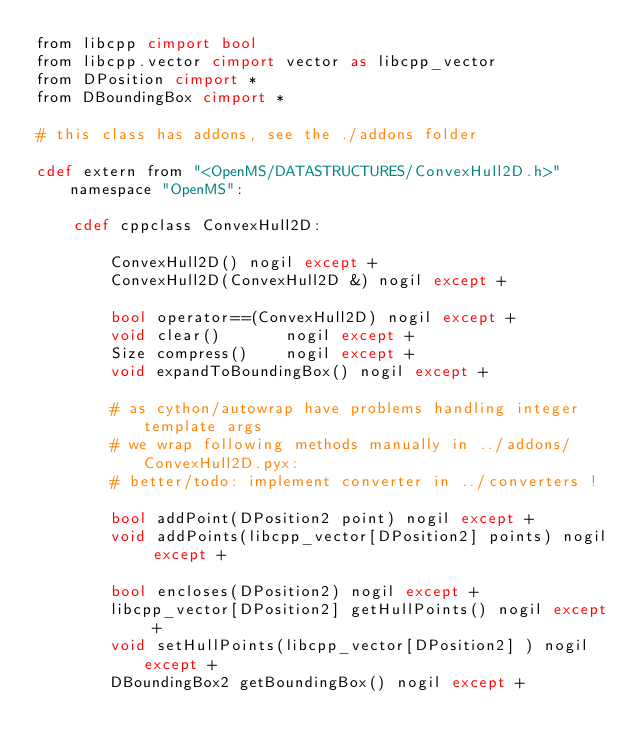<code> <loc_0><loc_0><loc_500><loc_500><_Cython_>from libcpp cimport bool
from libcpp.vector cimport vector as libcpp_vector
from DPosition cimport *
from DBoundingBox cimport *

# this class has addons, see the ./addons folder

cdef extern from "<OpenMS/DATASTRUCTURES/ConvexHull2D.h>" namespace "OpenMS":

    cdef cppclass ConvexHull2D:

        ConvexHull2D() nogil except +
        ConvexHull2D(ConvexHull2D &) nogil except +

        bool operator==(ConvexHull2D) nogil except +
        void clear()       nogil except +
        Size compress()    nogil except +
        void expandToBoundingBox() nogil except +

        # as cython/autowrap have problems handling integer template args
        # we wrap following methods manually in ../addons/ConvexHull2D.pyx:
        # better/todo: implement converter in ../converters !

        bool addPoint(DPosition2 point) nogil except +
        void addPoints(libcpp_vector[DPosition2] points) nogil except +

        bool encloses(DPosition2) nogil except +
        libcpp_vector[DPosition2] getHullPoints() nogil except + 
        void setHullPoints(libcpp_vector[DPosition2] ) nogil except + 
        DBoundingBox2 getBoundingBox() nogil except +

</code> 